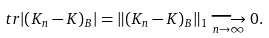<formula> <loc_0><loc_0><loc_500><loc_500>\ t r | ( K _ { n } - K ) _ { B } | = \| ( K _ { n } - K ) _ { B } \| _ { 1 } \underset { n \rightarrow \infty } { \longrightarrow } 0 .</formula> 